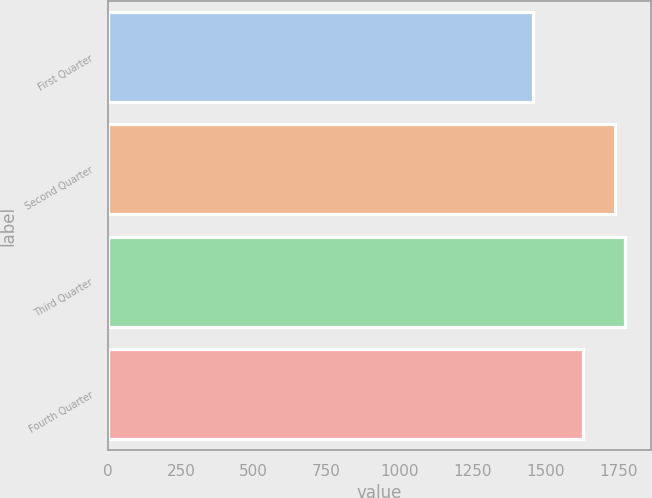Convert chart. <chart><loc_0><loc_0><loc_500><loc_500><bar_chart><fcel>First Quarter<fcel>Second Quarter<fcel>Third Quarter<fcel>Fourth Quarter<nl><fcel>1459.49<fcel>1738.34<fcel>1774.4<fcel>1630.56<nl></chart> 